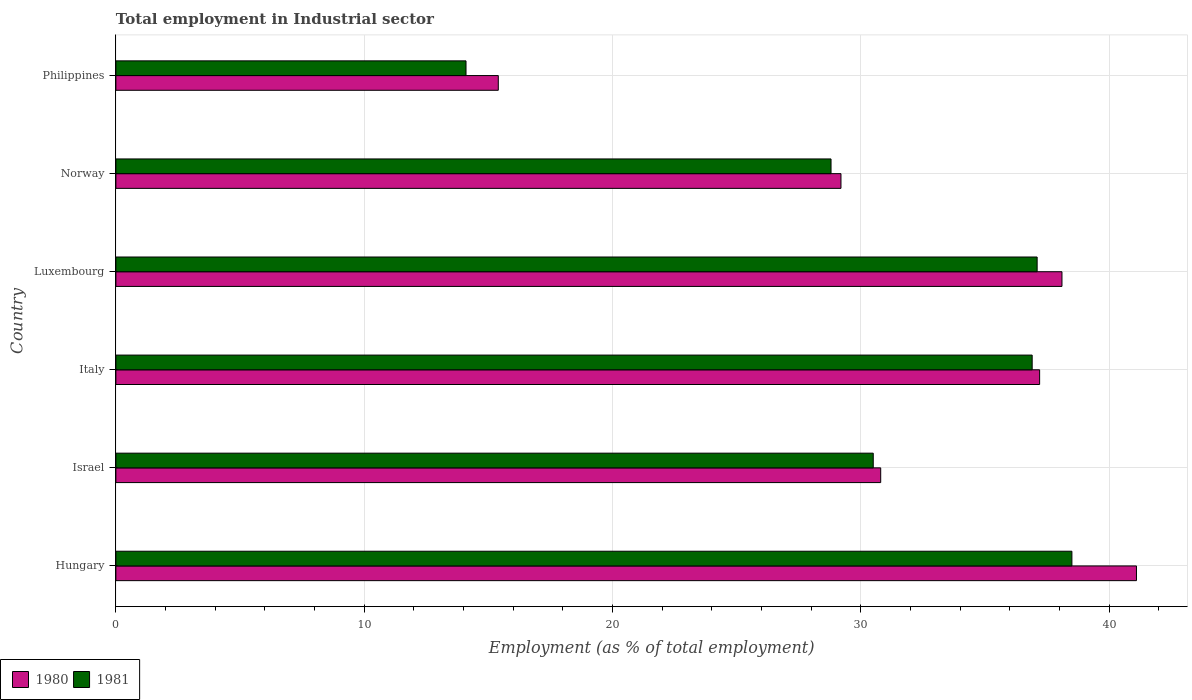How many different coloured bars are there?
Your response must be concise. 2. How many groups of bars are there?
Your answer should be compact. 6. Are the number of bars on each tick of the Y-axis equal?
Keep it short and to the point. Yes. What is the employment in industrial sector in 1981 in Israel?
Your answer should be compact. 30.5. Across all countries, what is the maximum employment in industrial sector in 1980?
Your answer should be very brief. 41.1. Across all countries, what is the minimum employment in industrial sector in 1981?
Offer a very short reply. 14.1. In which country was the employment in industrial sector in 1981 maximum?
Offer a very short reply. Hungary. In which country was the employment in industrial sector in 1981 minimum?
Ensure brevity in your answer.  Philippines. What is the total employment in industrial sector in 1980 in the graph?
Keep it short and to the point. 191.8. What is the difference between the employment in industrial sector in 1980 in Israel and that in Philippines?
Offer a terse response. 15.4. What is the difference between the employment in industrial sector in 1980 in Luxembourg and the employment in industrial sector in 1981 in Norway?
Your answer should be compact. 9.3. What is the average employment in industrial sector in 1981 per country?
Provide a succinct answer. 30.98. What is the difference between the employment in industrial sector in 1980 and employment in industrial sector in 1981 in Philippines?
Give a very brief answer. 1.3. What is the ratio of the employment in industrial sector in 1981 in Luxembourg to that in Philippines?
Make the answer very short. 2.63. Is the employment in industrial sector in 1980 in Israel less than that in Norway?
Your answer should be compact. No. What is the difference between the highest and the second highest employment in industrial sector in 1981?
Offer a very short reply. 1.4. What is the difference between the highest and the lowest employment in industrial sector in 1981?
Provide a succinct answer. 24.4. Is the sum of the employment in industrial sector in 1980 in Hungary and Norway greater than the maximum employment in industrial sector in 1981 across all countries?
Your response must be concise. Yes. How many bars are there?
Ensure brevity in your answer.  12. How many countries are there in the graph?
Make the answer very short. 6. What is the difference between two consecutive major ticks on the X-axis?
Your answer should be compact. 10. Does the graph contain grids?
Your answer should be compact. Yes. Where does the legend appear in the graph?
Your answer should be very brief. Bottom left. How many legend labels are there?
Provide a succinct answer. 2. What is the title of the graph?
Give a very brief answer. Total employment in Industrial sector. What is the label or title of the X-axis?
Your answer should be compact. Employment (as % of total employment). What is the label or title of the Y-axis?
Ensure brevity in your answer.  Country. What is the Employment (as % of total employment) of 1980 in Hungary?
Your answer should be very brief. 41.1. What is the Employment (as % of total employment) in 1981 in Hungary?
Give a very brief answer. 38.5. What is the Employment (as % of total employment) in 1980 in Israel?
Keep it short and to the point. 30.8. What is the Employment (as % of total employment) of 1981 in Israel?
Give a very brief answer. 30.5. What is the Employment (as % of total employment) of 1980 in Italy?
Provide a succinct answer. 37.2. What is the Employment (as % of total employment) of 1981 in Italy?
Provide a succinct answer. 36.9. What is the Employment (as % of total employment) in 1980 in Luxembourg?
Provide a succinct answer. 38.1. What is the Employment (as % of total employment) in 1981 in Luxembourg?
Your response must be concise. 37.1. What is the Employment (as % of total employment) in 1980 in Norway?
Ensure brevity in your answer.  29.2. What is the Employment (as % of total employment) of 1981 in Norway?
Provide a succinct answer. 28.8. What is the Employment (as % of total employment) in 1980 in Philippines?
Your answer should be very brief. 15.4. What is the Employment (as % of total employment) in 1981 in Philippines?
Offer a very short reply. 14.1. Across all countries, what is the maximum Employment (as % of total employment) of 1980?
Offer a terse response. 41.1. Across all countries, what is the maximum Employment (as % of total employment) of 1981?
Give a very brief answer. 38.5. Across all countries, what is the minimum Employment (as % of total employment) in 1980?
Keep it short and to the point. 15.4. Across all countries, what is the minimum Employment (as % of total employment) of 1981?
Provide a short and direct response. 14.1. What is the total Employment (as % of total employment) of 1980 in the graph?
Your answer should be very brief. 191.8. What is the total Employment (as % of total employment) in 1981 in the graph?
Make the answer very short. 185.9. What is the difference between the Employment (as % of total employment) in 1981 in Hungary and that in Israel?
Make the answer very short. 8. What is the difference between the Employment (as % of total employment) in 1981 in Hungary and that in Luxembourg?
Offer a very short reply. 1.4. What is the difference between the Employment (as % of total employment) of 1981 in Hungary and that in Norway?
Your response must be concise. 9.7. What is the difference between the Employment (as % of total employment) in 1980 in Hungary and that in Philippines?
Keep it short and to the point. 25.7. What is the difference between the Employment (as % of total employment) of 1981 in Hungary and that in Philippines?
Offer a terse response. 24.4. What is the difference between the Employment (as % of total employment) of 1981 in Israel and that in Italy?
Ensure brevity in your answer.  -6.4. What is the difference between the Employment (as % of total employment) of 1980 in Israel and that in Luxembourg?
Your response must be concise. -7.3. What is the difference between the Employment (as % of total employment) of 1981 in Israel and that in Luxembourg?
Keep it short and to the point. -6.6. What is the difference between the Employment (as % of total employment) of 1981 in Israel and that in Philippines?
Provide a succinct answer. 16.4. What is the difference between the Employment (as % of total employment) of 1980 in Italy and that in Norway?
Ensure brevity in your answer.  8. What is the difference between the Employment (as % of total employment) in 1980 in Italy and that in Philippines?
Provide a short and direct response. 21.8. What is the difference between the Employment (as % of total employment) in 1981 in Italy and that in Philippines?
Provide a short and direct response. 22.8. What is the difference between the Employment (as % of total employment) of 1980 in Luxembourg and that in Norway?
Make the answer very short. 8.9. What is the difference between the Employment (as % of total employment) of 1981 in Luxembourg and that in Norway?
Give a very brief answer. 8.3. What is the difference between the Employment (as % of total employment) of 1980 in Luxembourg and that in Philippines?
Your answer should be very brief. 22.7. What is the difference between the Employment (as % of total employment) in 1980 in Norway and that in Philippines?
Your response must be concise. 13.8. What is the difference between the Employment (as % of total employment) of 1981 in Norway and that in Philippines?
Keep it short and to the point. 14.7. What is the difference between the Employment (as % of total employment) in 1980 in Hungary and the Employment (as % of total employment) in 1981 in Luxembourg?
Make the answer very short. 4. What is the difference between the Employment (as % of total employment) in 1980 in Hungary and the Employment (as % of total employment) in 1981 in Philippines?
Your answer should be very brief. 27. What is the difference between the Employment (as % of total employment) of 1980 in Israel and the Employment (as % of total employment) of 1981 in Italy?
Your response must be concise. -6.1. What is the difference between the Employment (as % of total employment) in 1980 in Israel and the Employment (as % of total employment) in 1981 in Luxembourg?
Offer a very short reply. -6.3. What is the difference between the Employment (as % of total employment) in 1980 in Israel and the Employment (as % of total employment) in 1981 in Norway?
Your answer should be compact. 2. What is the difference between the Employment (as % of total employment) of 1980 in Italy and the Employment (as % of total employment) of 1981 in Philippines?
Provide a short and direct response. 23.1. What is the difference between the Employment (as % of total employment) in 1980 in Luxembourg and the Employment (as % of total employment) in 1981 in Norway?
Provide a succinct answer. 9.3. What is the difference between the Employment (as % of total employment) in 1980 in Norway and the Employment (as % of total employment) in 1981 in Philippines?
Ensure brevity in your answer.  15.1. What is the average Employment (as % of total employment) in 1980 per country?
Your response must be concise. 31.97. What is the average Employment (as % of total employment) in 1981 per country?
Keep it short and to the point. 30.98. What is the difference between the Employment (as % of total employment) in 1980 and Employment (as % of total employment) in 1981 in Hungary?
Ensure brevity in your answer.  2.6. What is the difference between the Employment (as % of total employment) in 1980 and Employment (as % of total employment) in 1981 in Israel?
Give a very brief answer. 0.3. What is the difference between the Employment (as % of total employment) of 1980 and Employment (as % of total employment) of 1981 in Italy?
Your answer should be compact. 0.3. What is the difference between the Employment (as % of total employment) in 1980 and Employment (as % of total employment) in 1981 in Luxembourg?
Your answer should be very brief. 1. What is the difference between the Employment (as % of total employment) of 1980 and Employment (as % of total employment) of 1981 in Norway?
Provide a succinct answer. 0.4. What is the ratio of the Employment (as % of total employment) in 1980 in Hungary to that in Israel?
Make the answer very short. 1.33. What is the ratio of the Employment (as % of total employment) in 1981 in Hungary to that in Israel?
Make the answer very short. 1.26. What is the ratio of the Employment (as % of total employment) in 1980 in Hungary to that in Italy?
Offer a very short reply. 1.1. What is the ratio of the Employment (as % of total employment) of 1981 in Hungary to that in Italy?
Ensure brevity in your answer.  1.04. What is the ratio of the Employment (as % of total employment) of 1980 in Hungary to that in Luxembourg?
Your answer should be very brief. 1.08. What is the ratio of the Employment (as % of total employment) of 1981 in Hungary to that in Luxembourg?
Your answer should be compact. 1.04. What is the ratio of the Employment (as % of total employment) in 1980 in Hungary to that in Norway?
Your answer should be compact. 1.41. What is the ratio of the Employment (as % of total employment) of 1981 in Hungary to that in Norway?
Your answer should be very brief. 1.34. What is the ratio of the Employment (as % of total employment) of 1980 in Hungary to that in Philippines?
Your answer should be compact. 2.67. What is the ratio of the Employment (as % of total employment) of 1981 in Hungary to that in Philippines?
Provide a short and direct response. 2.73. What is the ratio of the Employment (as % of total employment) in 1980 in Israel to that in Italy?
Give a very brief answer. 0.83. What is the ratio of the Employment (as % of total employment) of 1981 in Israel to that in Italy?
Your response must be concise. 0.83. What is the ratio of the Employment (as % of total employment) in 1980 in Israel to that in Luxembourg?
Your response must be concise. 0.81. What is the ratio of the Employment (as % of total employment) of 1981 in Israel to that in Luxembourg?
Your response must be concise. 0.82. What is the ratio of the Employment (as % of total employment) of 1980 in Israel to that in Norway?
Provide a short and direct response. 1.05. What is the ratio of the Employment (as % of total employment) of 1981 in Israel to that in Norway?
Your answer should be very brief. 1.06. What is the ratio of the Employment (as % of total employment) in 1980 in Israel to that in Philippines?
Make the answer very short. 2. What is the ratio of the Employment (as % of total employment) of 1981 in Israel to that in Philippines?
Your answer should be compact. 2.16. What is the ratio of the Employment (as % of total employment) of 1980 in Italy to that in Luxembourg?
Offer a terse response. 0.98. What is the ratio of the Employment (as % of total employment) in 1980 in Italy to that in Norway?
Your answer should be compact. 1.27. What is the ratio of the Employment (as % of total employment) of 1981 in Italy to that in Norway?
Your answer should be very brief. 1.28. What is the ratio of the Employment (as % of total employment) in 1980 in Italy to that in Philippines?
Provide a short and direct response. 2.42. What is the ratio of the Employment (as % of total employment) in 1981 in Italy to that in Philippines?
Provide a short and direct response. 2.62. What is the ratio of the Employment (as % of total employment) of 1980 in Luxembourg to that in Norway?
Ensure brevity in your answer.  1.3. What is the ratio of the Employment (as % of total employment) in 1981 in Luxembourg to that in Norway?
Provide a short and direct response. 1.29. What is the ratio of the Employment (as % of total employment) of 1980 in Luxembourg to that in Philippines?
Keep it short and to the point. 2.47. What is the ratio of the Employment (as % of total employment) in 1981 in Luxembourg to that in Philippines?
Offer a terse response. 2.63. What is the ratio of the Employment (as % of total employment) in 1980 in Norway to that in Philippines?
Offer a terse response. 1.9. What is the ratio of the Employment (as % of total employment) of 1981 in Norway to that in Philippines?
Offer a terse response. 2.04. What is the difference between the highest and the lowest Employment (as % of total employment) in 1980?
Make the answer very short. 25.7. What is the difference between the highest and the lowest Employment (as % of total employment) in 1981?
Ensure brevity in your answer.  24.4. 